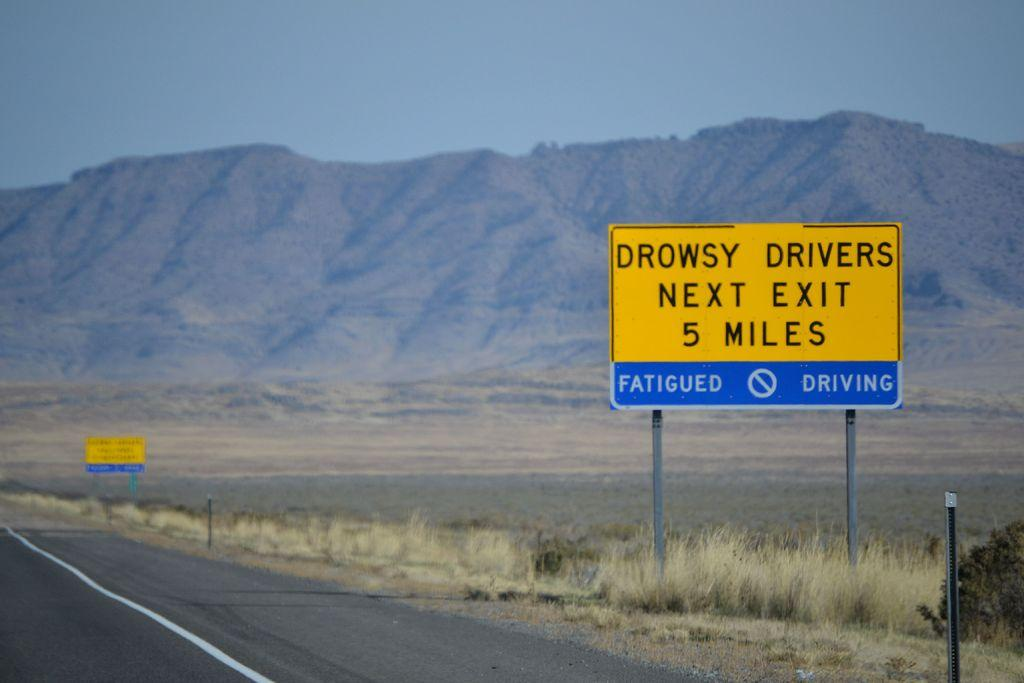Provide a one-sentence caption for the provided image. a yellow sign that has the word drowsy on it. 